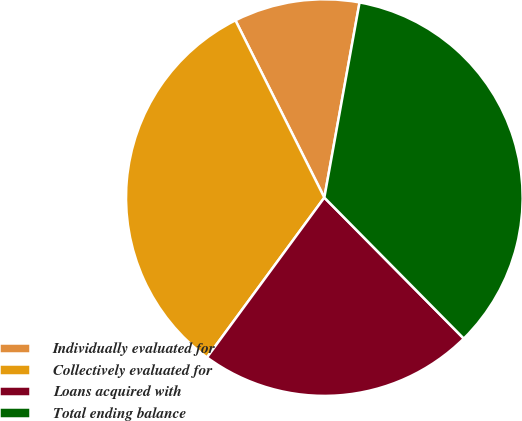<chart> <loc_0><loc_0><loc_500><loc_500><pie_chart><fcel>Individually evaluated for<fcel>Collectively evaluated for<fcel>Loans acquired with<fcel>Total ending balance<nl><fcel>10.24%<fcel>32.52%<fcel>22.49%<fcel>34.74%<nl></chart> 